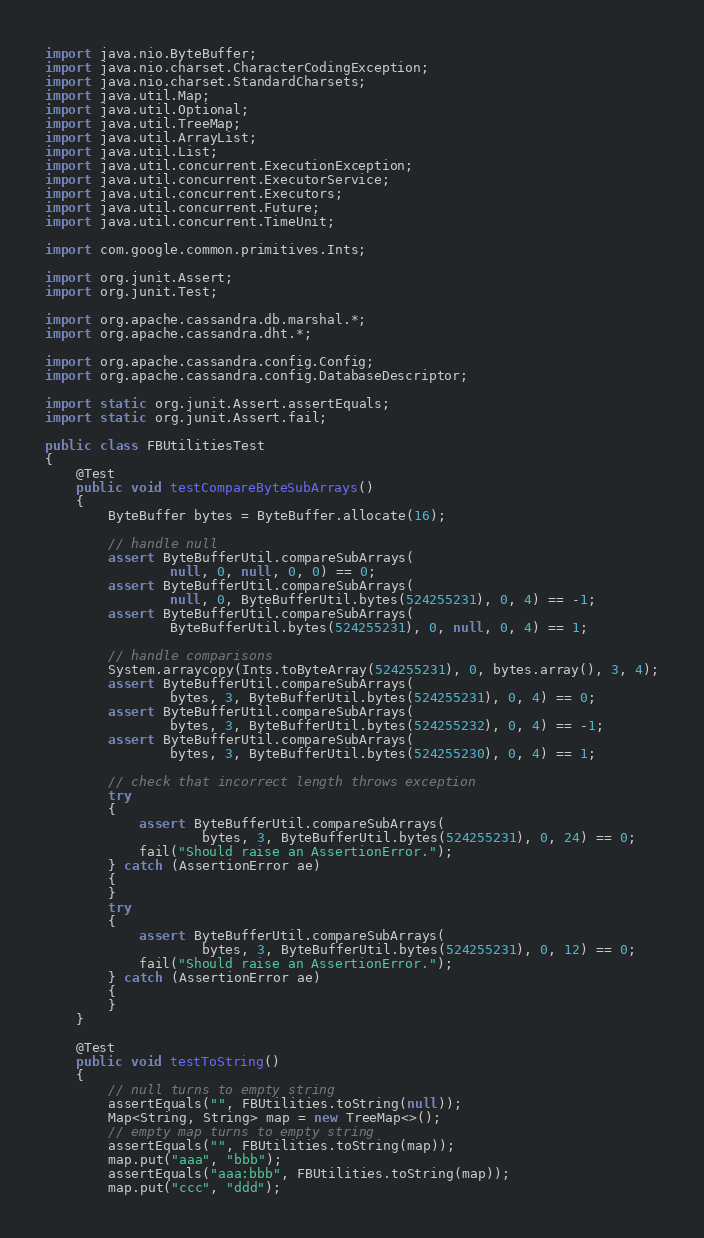<code> <loc_0><loc_0><loc_500><loc_500><_Java_>import java.nio.ByteBuffer;
import java.nio.charset.CharacterCodingException;
import java.nio.charset.StandardCharsets;
import java.util.Map;
import java.util.Optional;
import java.util.TreeMap;
import java.util.ArrayList;
import java.util.List;
import java.util.concurrent.ExecutionException;
import java.util.concurrent.ExecutorService;
import java.util.concurrent.Executors;
import java.util.concurrent.Future;
import java.util.concurrent.TimeUnit;

import com.google.common.primitives.Ints;

import org.junit.Assert;
import org.junit.Test;

import org.apache.cassandra.db.marshal.*;
import org.apache.cassandra.dht.*;

import org.apache.cassandra.config.Config;
import org.apache.cassandra.config.DatabaseDescriptor;

import static org.junit.Assert.assertEquals;
import static org.junit.Assert.fail;

public class FBUtilitiesTest
{
    @Test
    public void testCompareByteSubArrays()
    {
        ByteBuffer bytes = ByteBuffer.allocate(16);

        // handle null
        assert ByteBufferUtil.compareSubArrays(
                null, 0, null, 0, 0) == 0;
        assert ByteBufferUtil.compareSubArrays(
                null, 0, ByteBufferUtil.bytes(524255231), 0, 4) == -1;
        assert ByteBufferUtil.compareSubArrays(
                ByteBufferUtil.bytes(524255231), 0, null, 0, 4) == 1;

        // handle comparisons
        System.arraycopy(Ints.toByteArray(524255231), 0, bytes.array(), 3, 4);
        assert ByteBufferUtil.compareSubArrays(
                bytes, 3, ByteBufferUtil.bytes(524255231), 0, 4) == 0;
        assert ByteBufferUtil.compareSubArrays(
                bytes, 3, ByteBufferUtil.bytes(524255232), 0, 4) == -1;
        assert ByteBufferUtil.compareSubArrays(
                bytes, 3, ByteBufferUtil.bytes(524255230), 0, 4) == 1;

        // check that incorrect length throws exception
        try
        {
            assert ByteBufferUtil.compareSubArrays(
                    bytes, 3, ByteBufferUtil.bytes(524255231), 0, 24) == 0;
            fail("Should raise an AssertionError.");
        } catch (AssertionError ae)
        {
        }
        try
        {
            assert ByteBufferUtil.compareSubArrays(
                    bytes, 3, ByteBufferUtil.bytes(524255231), 0, 12) == 0;
            fail("Should raise an AssertionError.");
        } catch (AssertionError ae)
        {
        }
    }

    @Test
    public void testToString()
    {
        // null turns to empty string
        assertEquals("", FBUtilities.toString(null));
        Map<String, String> map = new TreeMap<>();
        // empty map turns to empty string
        assertEquals("", FBUtilities.toString(map));
        map.put("aaa", "bbb");
        assertEquals("aaa:bbb", FBUtilities.toString(map));
        map.put("ccc", "ddd");</code> 